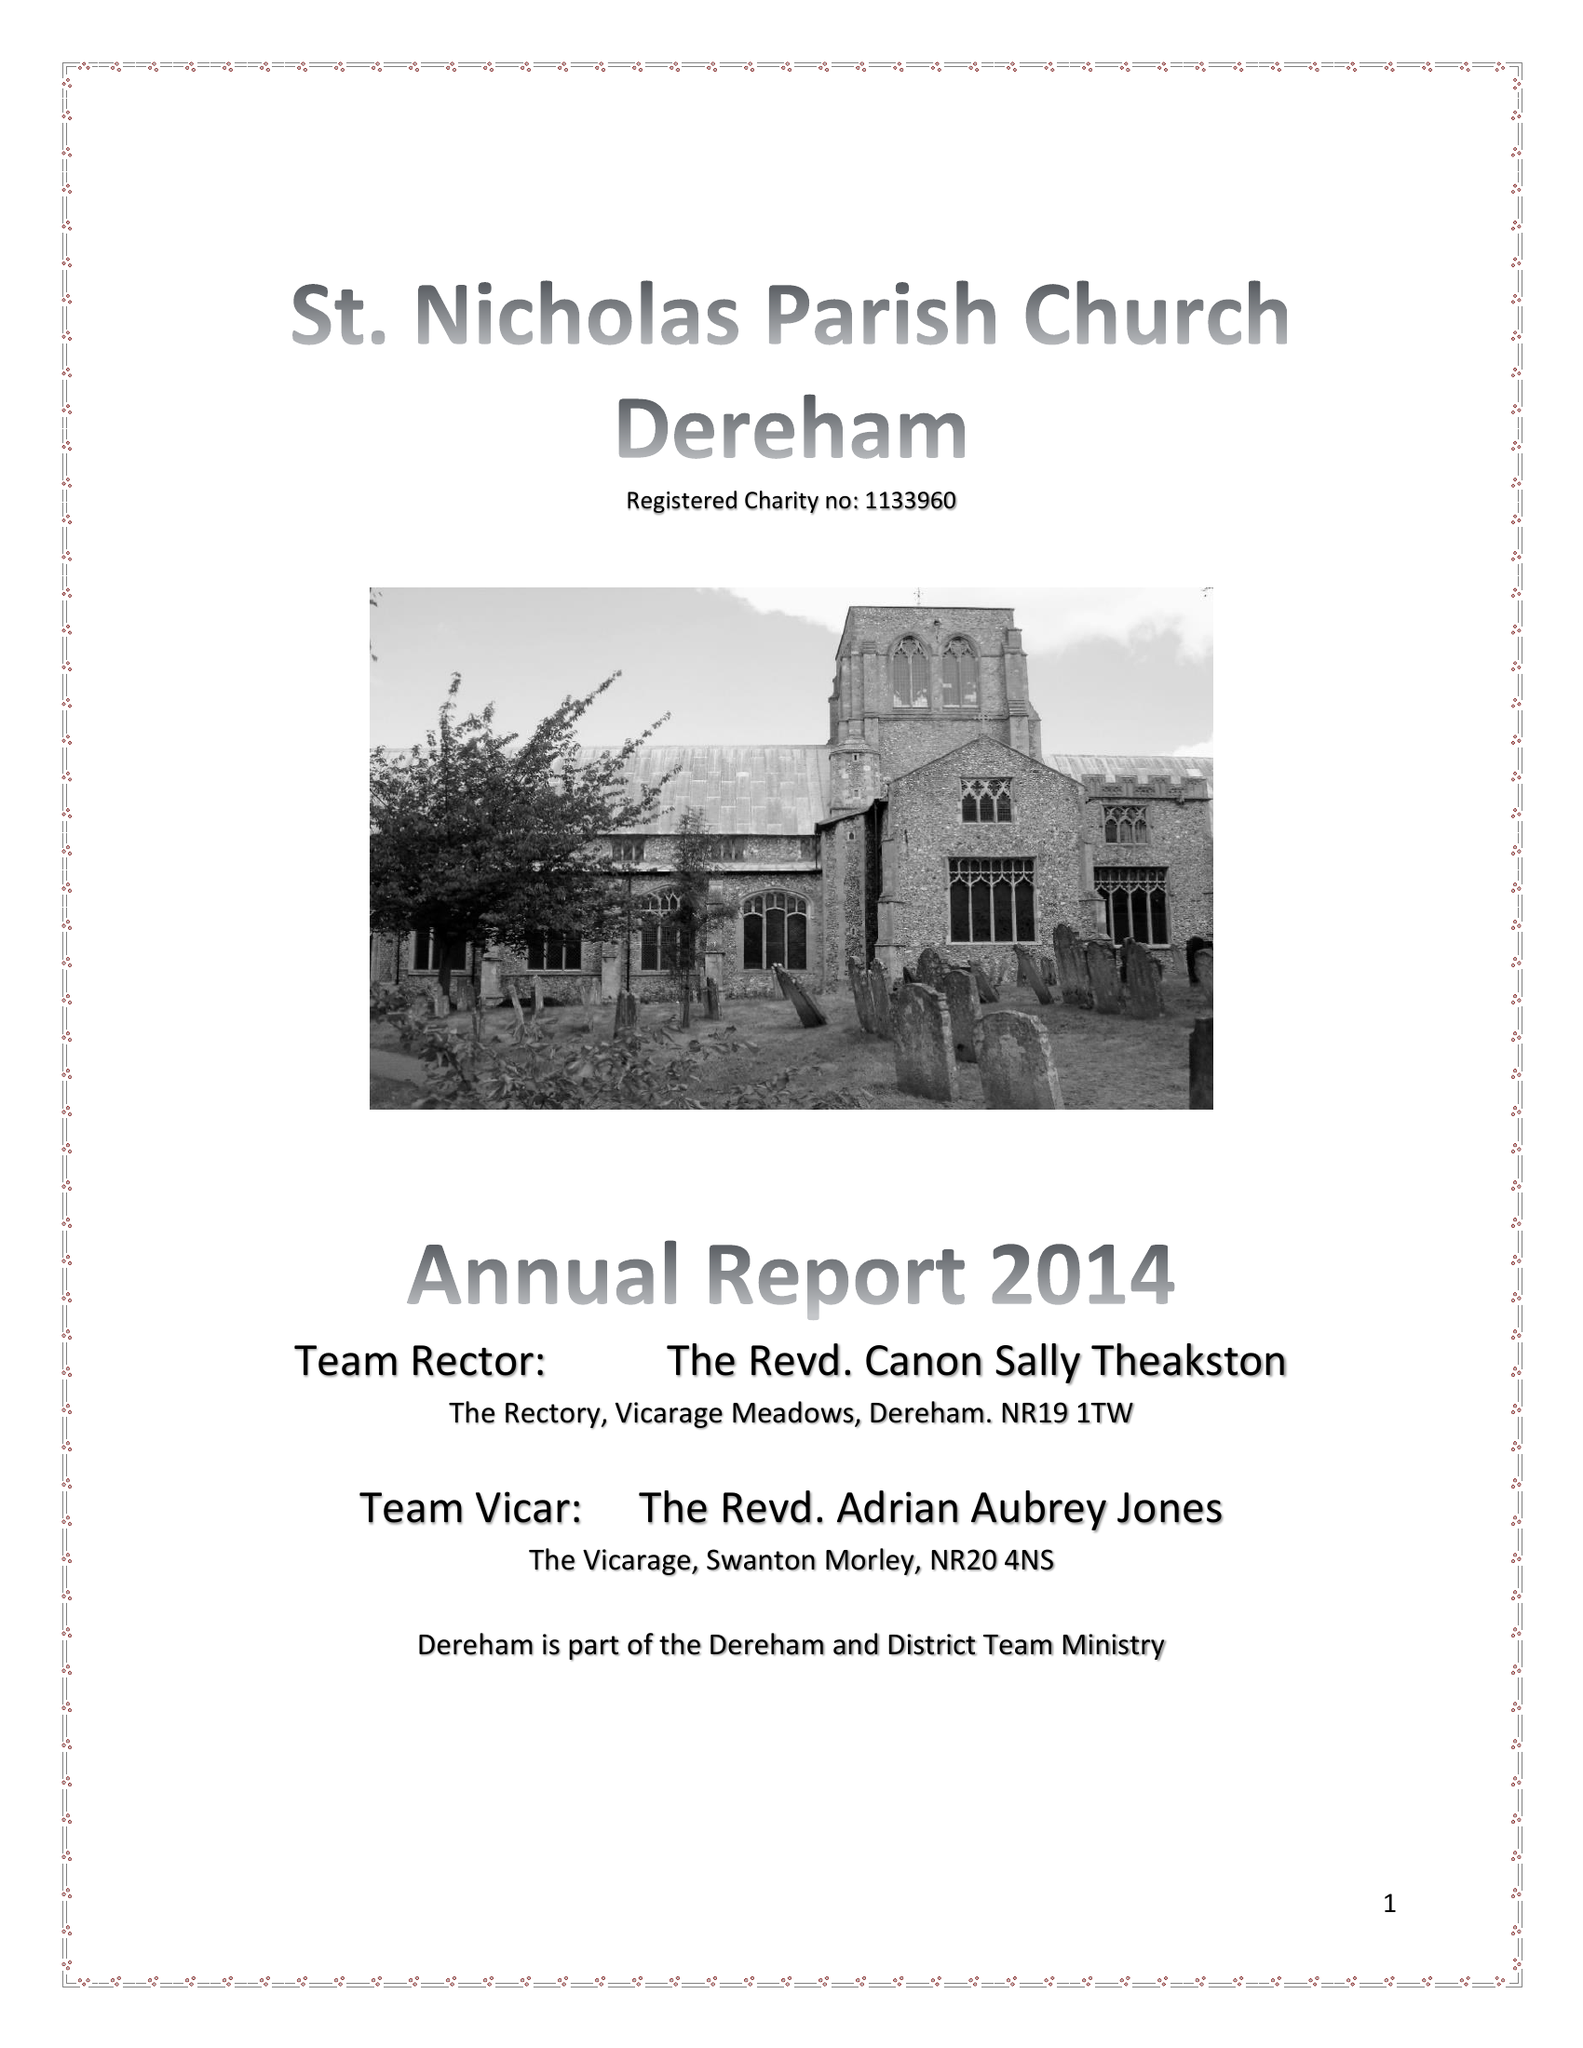What is the value for the address__postcode?
Answer the question using a single word or phrase. NR19 1DN 